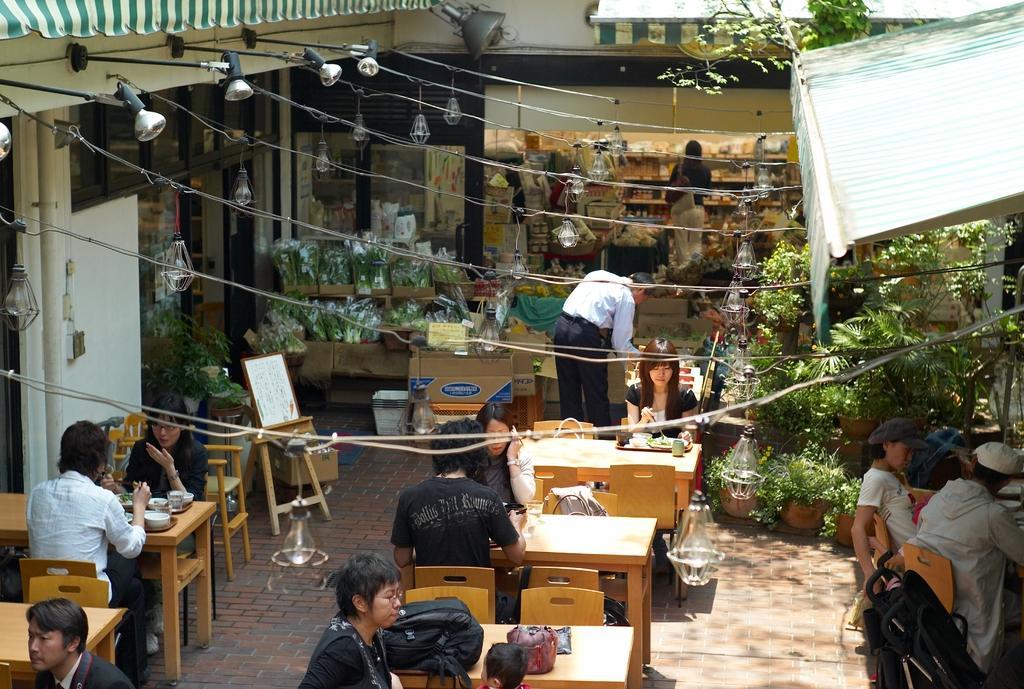Can you describe this image briefly? In this picture we can see persons some are sitting on chairs and some are standing and in front of them there is table and on table we can see bowl, plate, bags, glass, tray and in background we can see flower bouquets, house, sun shade, trees, lamp, bulbs. 